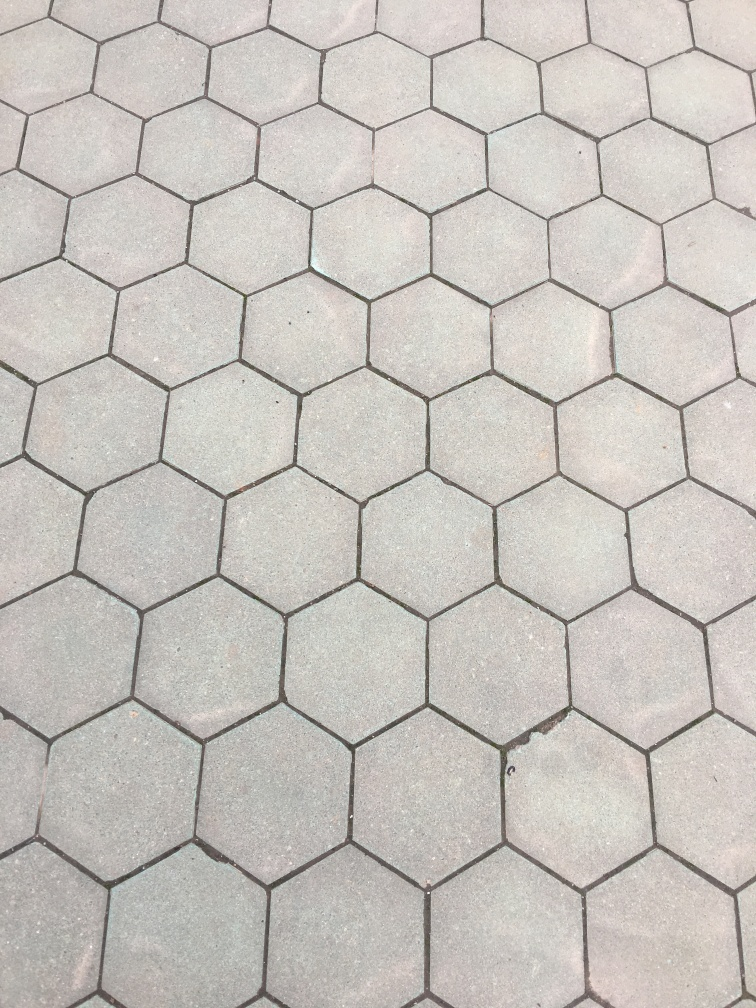What does the pattern in this image suggest about pedestrian traffic? The hexagonal pattern of the pavement is designed to be durable and aesthetically pleasing. It suggests a high-traffic pedestrian area where the choice of interlocking shapes provides stability and reduced wear over time. Could there be any symbolic meaning attached to this pattern? In fact, hexagons are often found in nature, like in honeycomb structures, which symbolize efficiency and strength. In urban design, the use of this pattern could be seen as drawing inspiration from nature, symbolizing harmony between the built environment and natural forms. 